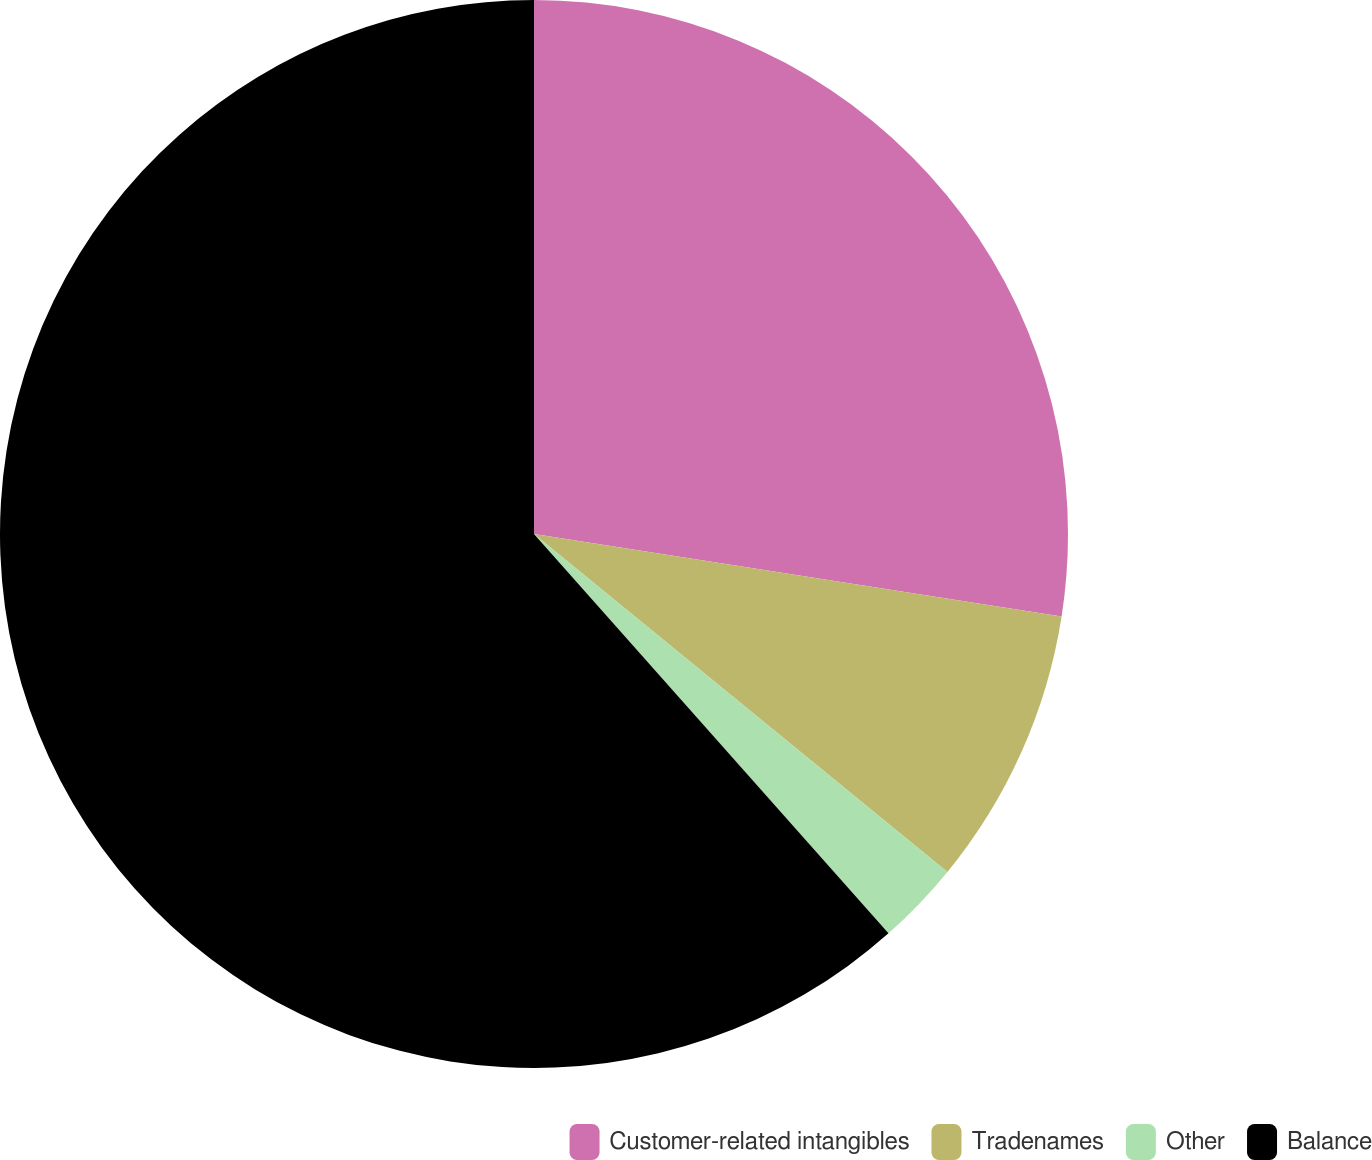<chart> <loc_0><loc_0><loc_500><loc_500><pie_chart><fcel>Customer-related intangibles<fcel>Tradenames<fcel>Other<fcel>Balance<nl><fcel>27.47%<fcel>8.44%<fcel>2.54%<fcel>61.56%<nl></chart> 